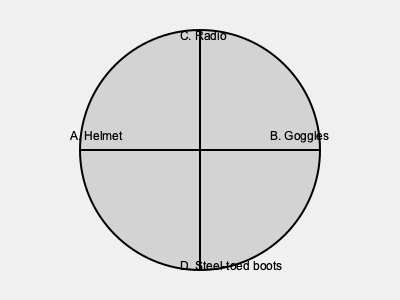As a concerned sibling, which of the following safety equipment items would you consider most crucial for your storm chaser brother or sister to have during a dangerous weather event? To determine the most crucial safety equipment for a storm chaser, we need to consider the primary dangers they face:

1. Flying debris: This is one of the most significant risks during severe storms, particularly tornadoes.
2. Limited visibility: Heavy rain, hail, and dust can severely impair vision.
3. Communication issues: Maintaining contact with team members and receiving weather updates is vital.
4. Potential for slips and falls: Wet or debris-covered surfaces can be hazardous.

Analyzing the options:

A. Helmet: Provides crucial protection against flying debris and potential head injuries.
B. Goggles: Offer some protection for the eyes but don't address the main risks.
C. Radio: Essential for communication and receiving weather updates, but doesn't provide physical protection.
D. Steel-toed boots: Provide foot protection but don't address the primary dangers.

The helmet (A) offers the most critical protection against the primary danger of flying debris, which can cause severe head injuries. While all items are important, the helmet is the most crucial for immediate physical safety in dangerous weather conditions.
Answer: Helmet 